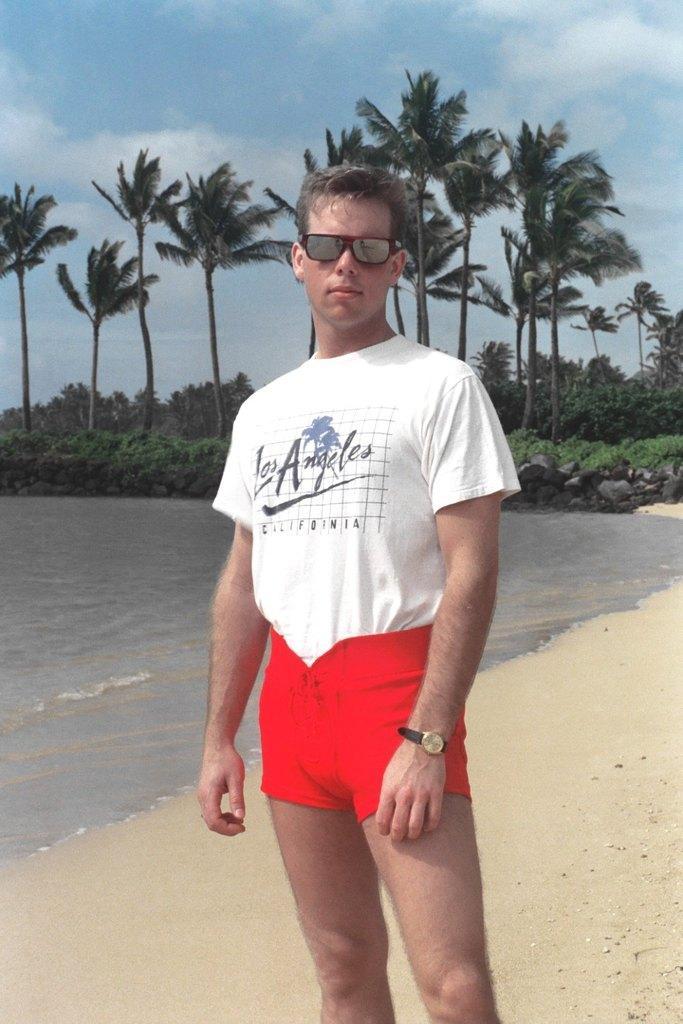How would you summarize this image in a sentence or two? In this picture we can see a man wearing a white t-shirt and red shorts, standing in the front and giving a pose to the camera. Behind there is a beach and sea water. In the background we can see some coconut trees. 